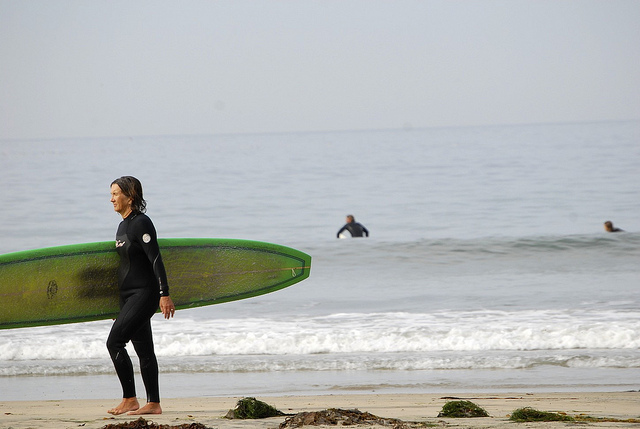If there were a dolphin jumping out of the water in the image, would you be able to see it? No, there is no dolphin visible in the image. The scene shows a calm ocean with some surfers, but no dolphin or any other marine animal can be seen jumping out of the water. 